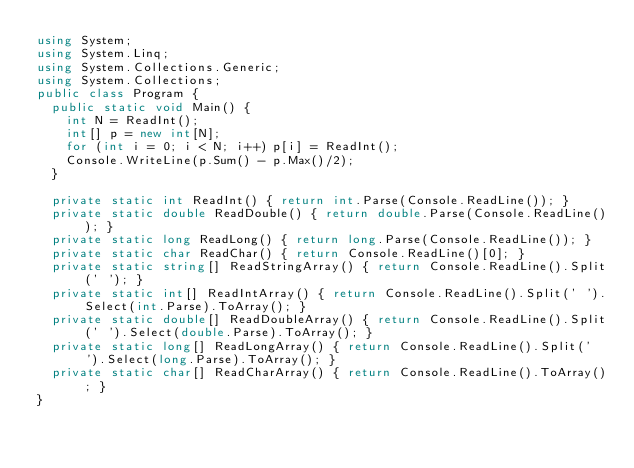Convert code to text. <code><loc_0><loc_0><loc_500><loc_500><_C#_>using System;
using System.Linq;
using System.Collections.Generic;
using System.Collections;
public class Program {
  public static void Main() {
    int N = ReadInt();
    int[] p = new int[N];
    for (int i = 0; i < N; i++) p[i] = ReadInt();
    Console.WriteLine(p.Sum() - p.Max()/2);
  }

  private static int ReadInt() { return int.Parse(Console.ReadLine()); }
  private static double ReadDouble() { return double.Parse(Console.ReadLine()); }
  private static long ReadLong() { return long.Parse(Console.ReadLine()); }
  private static char ReadChar() { return Console.ReadLine()[0]; }
  private static string[] ReadStringArray() { return Console.ReadLine().Split(' '); }
  private static int[] ReadIntArray() { return Console.ReadLine().Split(' ').Select(int.Parse).ToArray(); }
  private static double[] ReadDoubleArray() { return Console.ReadLine().Split(' ').Select(double.Parse).ToArray(); }
  private static long[] ReadLongArray() { return Console.ReadLine().Split(' ').Select(long.Parse).ToArray(); }
  private static char[] ReadCharArray() { return Console.ReadLine().ToArray(); }
}
</code> 